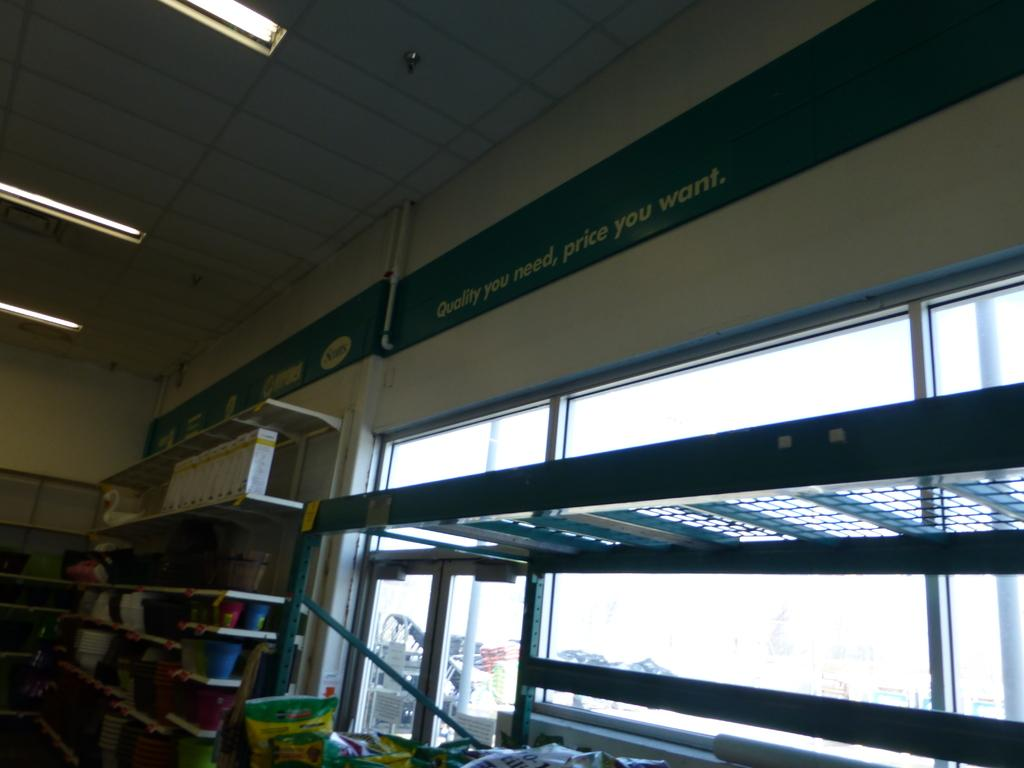<image>
Render a clear and concise summary of the photo. A sign is over the store shelves which states "quality you need, price you want but the shelves are almost bare. 